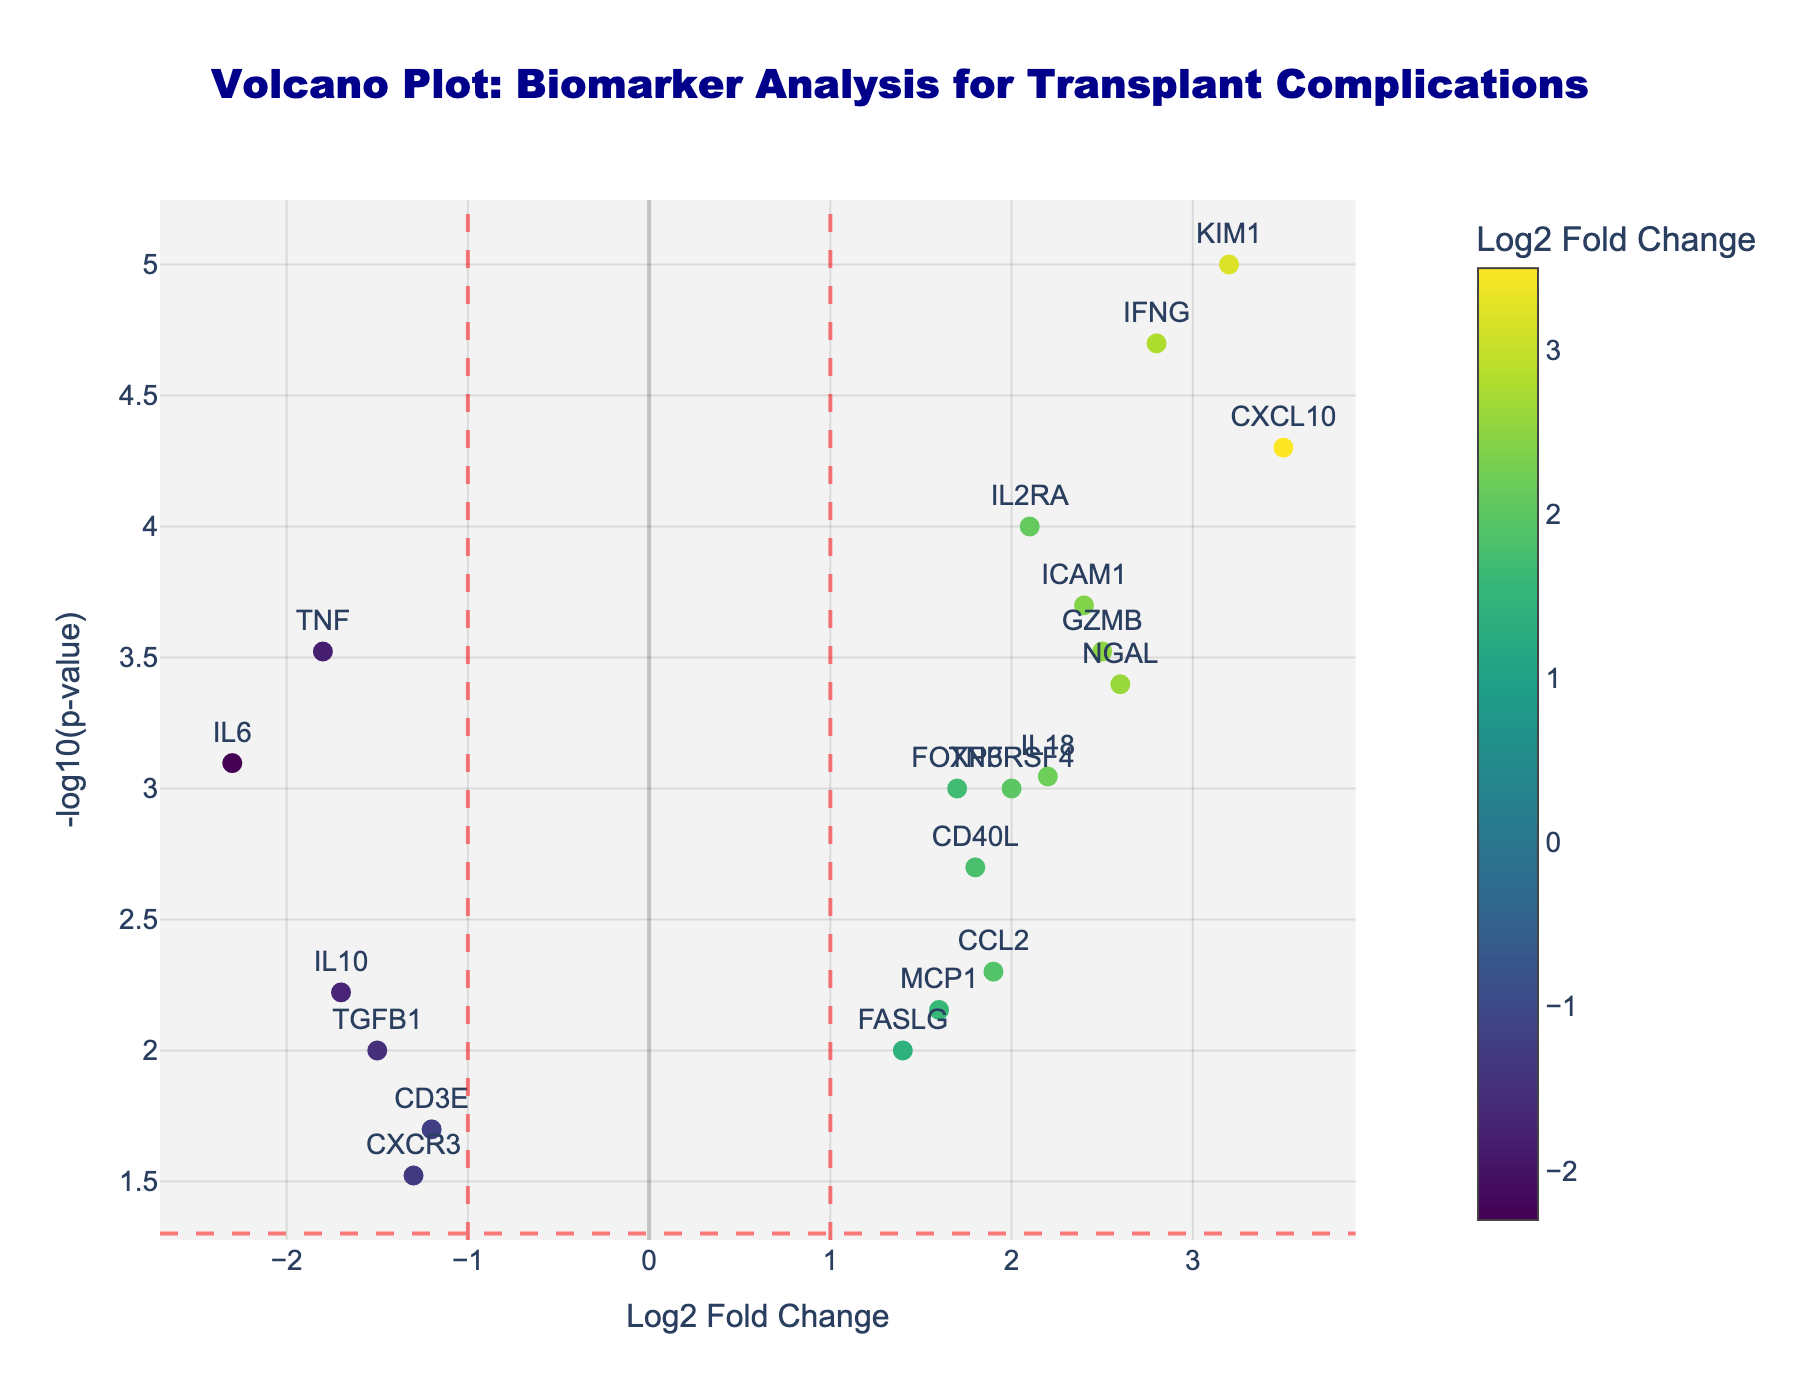What is the title of the plot? The title of the plot is typically found at the top of the figure. For this plot, it is located centrally at the top in dark blue, Arial Black font.
Answer: Volcano Plot: Biomarker Analysis for Transplant Complications How many biomarkers have a log2 fold change greater than 2? To answer this, identify all points to the right of the vertical dashed line at log2 fold change = 2. The markers KIM1, CXCL10, IFNG, IL2RA, and ICAM1 meet this criterion.
Answer: 5 Which biomarker has the lowest p-value? The lowest p-value corresponds to the highest -log10(p-value). Here, the highest point on the y-axis is the gene KIM1.
Answer: KIM1 What marker has the highest -log10(p-value)? -log10(p-value) is displayed on the y-axis. By finding the data point positioned highest on this axis, we identify KIM1.
Answer: KIM1 What is the log2 fold change and -log10(p-value) for IL2RA? Locate the point labeled IL2RA in the plot. Hovering over it (or visual inspection) shows the coordinates as roughly (2.1, 4).
Answer: Log2FC: 2.1, -log10(p-value): 4 Are there any biomarkers with a log2 fold change less than -2? To answer this, check the points to the left of the vertical dashed line at log2 fold change = -2. The only marker in this range is IL6.
Answer: IL6 How many biomarkers have p-values less than 0.05? The horizontal dashed line corresponds to -log10(0.05) = 1.3. Count the data points above this line. There are 9 such points.
Answer: 9 Which biomarker has a log2 fold change closest to zero? Identify the point closest to the x-axis origin (log2 fold change = 0). CD3E (log2FC: -1.2) fits this criterion.
Answer: CD3E Which biomarker is represented by the marker with the highest log2 fold change? The x-axis represents log2 fold change. The rightmost point (highest log2 fold change) is CXCL10 (log2FC: 3.5).
Answer: CXCL10 What is the log2 fold change and -log10(p-value) for the biomarker MCP1? Find MCP1 in the plot and note its coordinates: (1.6, 2.15).
Answer: Log2FC: 1.6, -log10(p-value): 2.15 